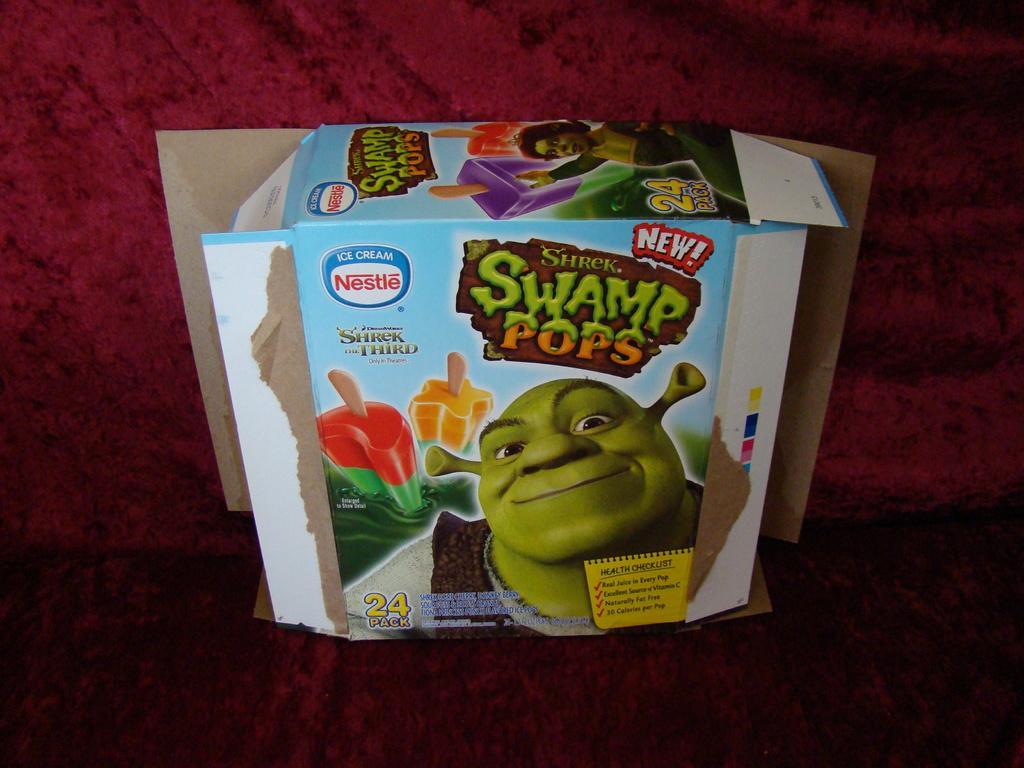In one or two sentences, can you explain what this image depicts? In the picture we can see a red color surface on it, we can see some box which opens on two sides and written on it as swamp pop. 